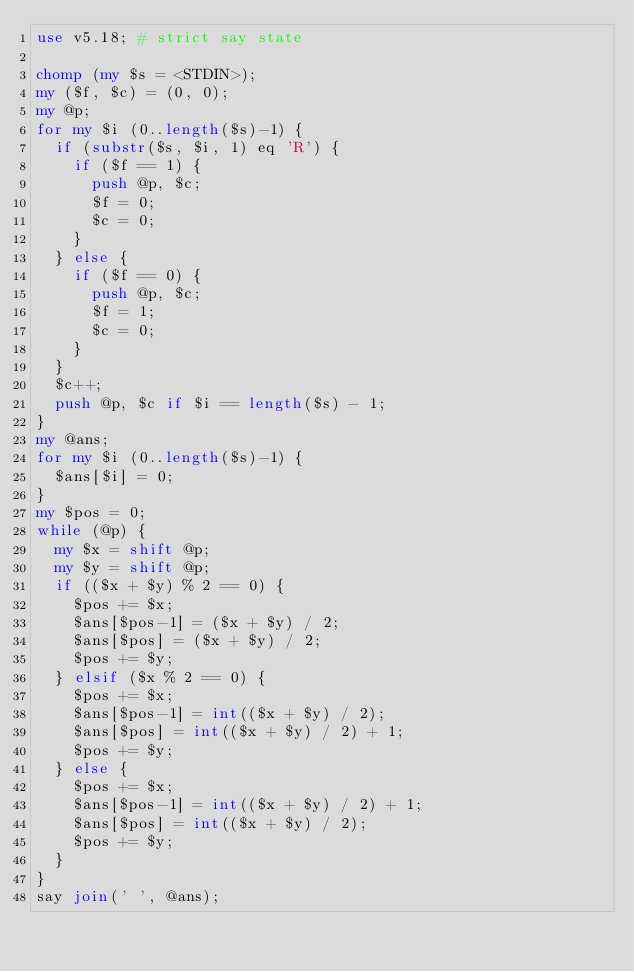Convert code to text. <code><loc_0><loc_0><loc_500><loc_500><_Perl_>use v5.18; # strict say state

chomp (my $s = <STDIN>);
my ($f, $c) = (0, 0);
my @p;
for my $i (0..length($s)-1) {
  if (substr($s, $i, 1) eq 'R') {
    if ($f == 1) {
      push @p, $c;
      $f = 0;
      $c = 0;
    }
  } else {
    if ($f == 0) {
      push @p, $c;
      $f = 1;
      $c = 0;
    }
  }
  $c++;
  push @p, $c if $i == length($s) - 1;
}
my @ans;
for my $i (0..length($s)-1) {
  $ans[$i] = 0;
}
my $pos = 0;
while (@p) {
  my $x = shift @p;
  my $y = shift @p;
  if (($x + $y) % 2 == 0) {
    $pos += $x;
    $ans[$pos-1] = ($x + $y) / 2;
    $ans[$pos] = ($x + $y) / 2;
    $pos += $y;
  } elsif ($x % 2 == 0) {
    $pos += $x;
    $ans[$pos-1] = int(($x + $y) / 2);
    $ans[$pos] = int(($x + $y) / 2) + 1;
    $pos += $y;
  } else {
    $pos += $x;
    $ans[$pos-1] = int(($x + $y) / 2) + 1;
    $ans[$pos] = int(($x + $y) / 2);
    $pos += $y;
  }
}
say join(' ', @ans);</code> 